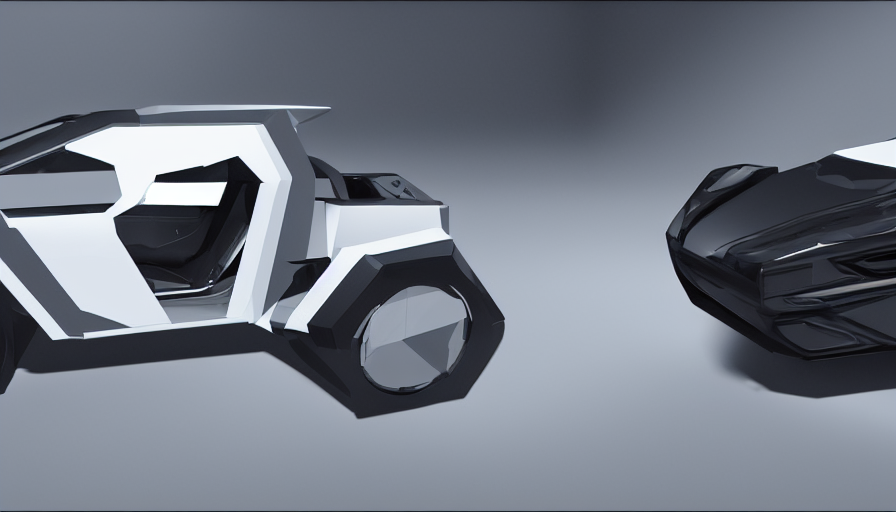These objects appear to be futuristic. What could be their possible function or story? The objects exude a futuristic aesthetic, reminiscent of advanced technology or vehicles from a sci-fi narrative. The one on the left, with its aerodynamic angles and what appears to be a cockpit, could be a concept for a high-speed personal transport vehicle. The one on the right, sleek and sharp, might be its automated drone companion or a modular part of the primary vehicle itself. Together, they tell a story of innovation and sophistication, potentially set in a world where transportation has evolved into forms that are as efficient as they are visually striking. 